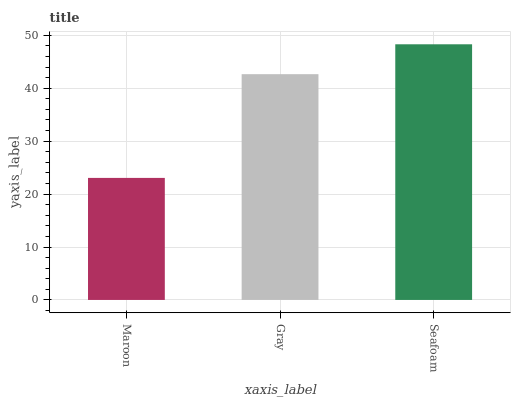Is Maroon the minimum?
Answer yes or no. Yes. Is Seafoam the maximum?
Answer yes or no. Yes. Is Gray the minimum?
Answer yes or no. No. Is Gray the maximum?
Answer yes or no. No. Is Gray greater than Maroon?
Answer yes or no. Yes. Is Maroon less than Gray?
Answer yes or no. Yes. Is Maroon greater than Gray?
Answer yes or no. No. Is Gray less than Maroon?
Answer yes or no. No. Is Gray the high median?
Answer yes or no. Yes. Is Gray the low median?
Answer yes or no. Yes. Is Maroon the high median?
Answer yes or no. No. Is Seafoam the low median?
Answer yes or no. No. 